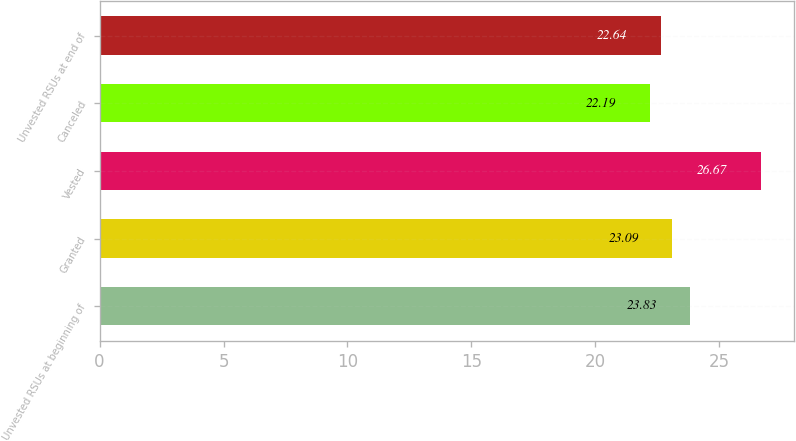<chart> <loc_0><loc_0><loc_500><loc_500><bar_chart><fcel>Unvested RSUs at beginning of<fcel>Granted<fcel>Vested<fcel>Canceled<fcel>Unvested RSUs at end of<nl><fcel>23.83<fcel>23.09<fcel>26.67<fcel>22.19<fcel>22.64<nl></chart> 